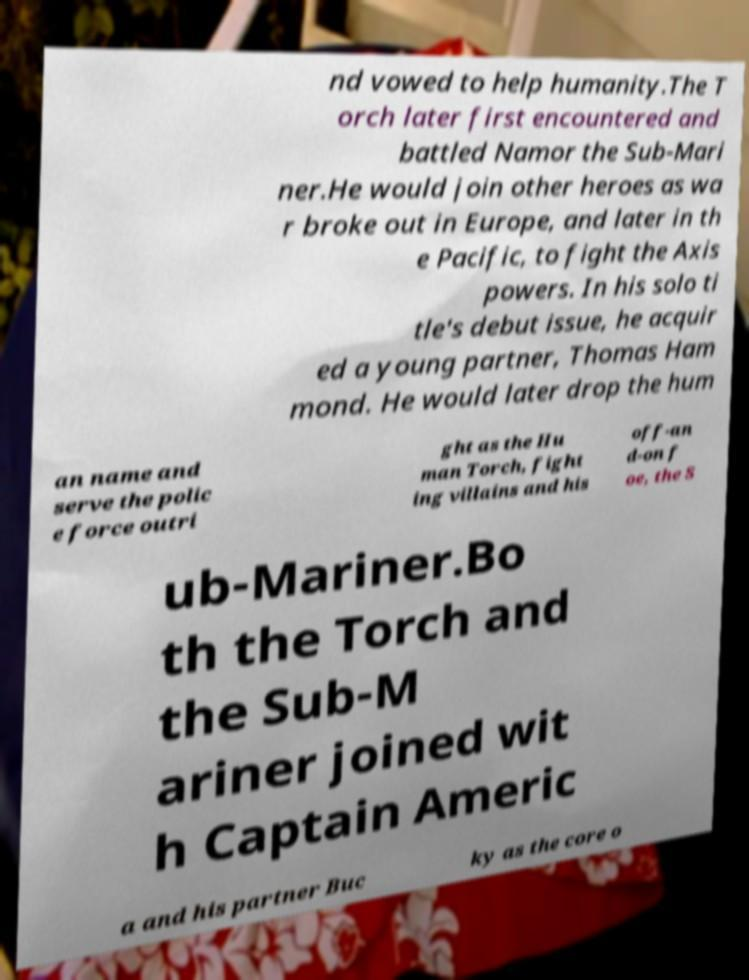For documentation purposes, I need the text within this image transcribed. Could you provide that? nd vowed to help humanity.The T orch later first encountered and battled Namor the Sub-Mari ner.He would join other heroes as wa r broke out in Europe, and later in th e Pacific, to fight the Axis powers. In his solo ti tle's debut issue, he acquir ed a young partner, Thomas Ham mond. He would later drop the hum an name and serve the polic e force outri ght as the Hu man Torch, fight ing villains and his off-an d-on f oe, the S ub-Mariner.Bo th the Torch and the Sub-M ariner joined wit h Captain Americ a and his partner Buc ky as the core o 